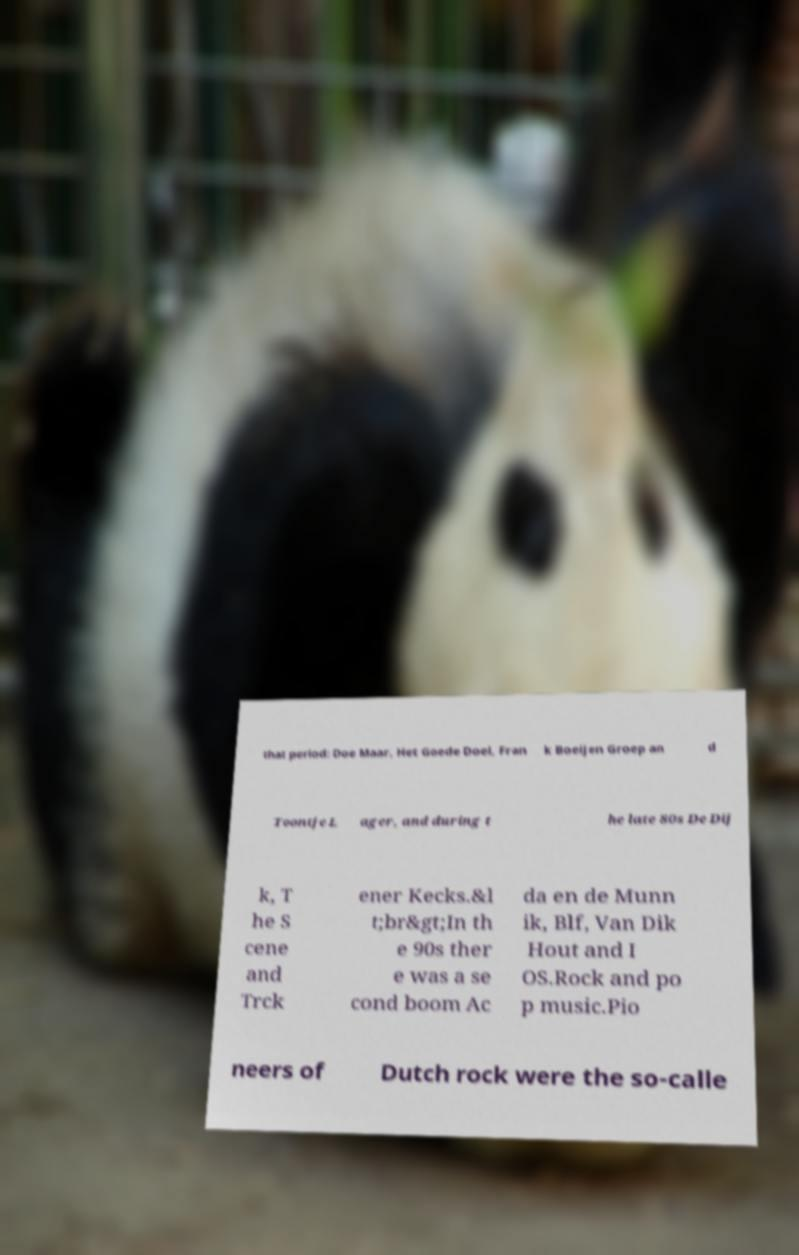There's text embedded in this image that I need extracted. Can you transcribe it verbatim? that period: Doe Maar, Het Goede Doel, Fran k Boeijen Groep an d Toontje L ager, and during t he late 80s De Dij k, T he S cene and Trck ener Kecks.&l t;br&gt;In th e 90s ther e was a se cond boom Ac da en de Munn ik, Blf, Van Dik Hout and I OS.Rock and po p music.Pio neers of Dutch rock were the so-calle 